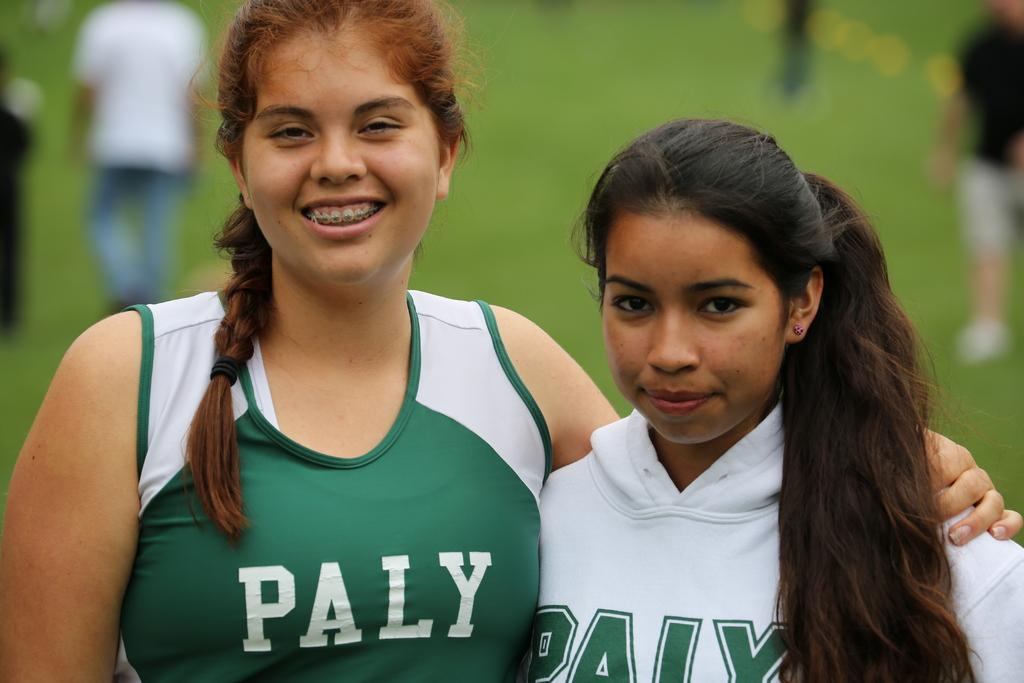How many girls are in the foreground of the image? There are two girls in the foreground of the image. What are the girls doing in the image? The girls are standing and smiling. What can be seen in the background of the image? There are people in the background of the image. What are the people in the background doing? The people in the background are walking. What type of terrain is visible in the image? There is grass visible in the image. Can you see any snails crawling on the grass in the image? There is no mention of snails in the image, so we cannot determine if any are present. 